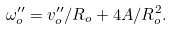Convert formula to latex. <formula><loc_0><loc_0><loc_500><loc_500>\omega _ { o } ^ { \prime \prime } = v _ { o } ^ { \prime \prime } / R _ { o } + 4 A / R _ { o } ^ { 2 } .</formula> 